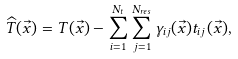<formula> <loc_0><loc_0><loc_500><loc_500>\widehat { T } ( \vec { x } ) = T ( \vec { x } ) - \sum _ { i = 1 } ^ { N _ { t } } \sum _ { j = 1 } ^ { N _ { r e s } } \gamma _ { i j } ( \vec { x } ) t _ { i j } ( \vec { x } ) ,</formula> 